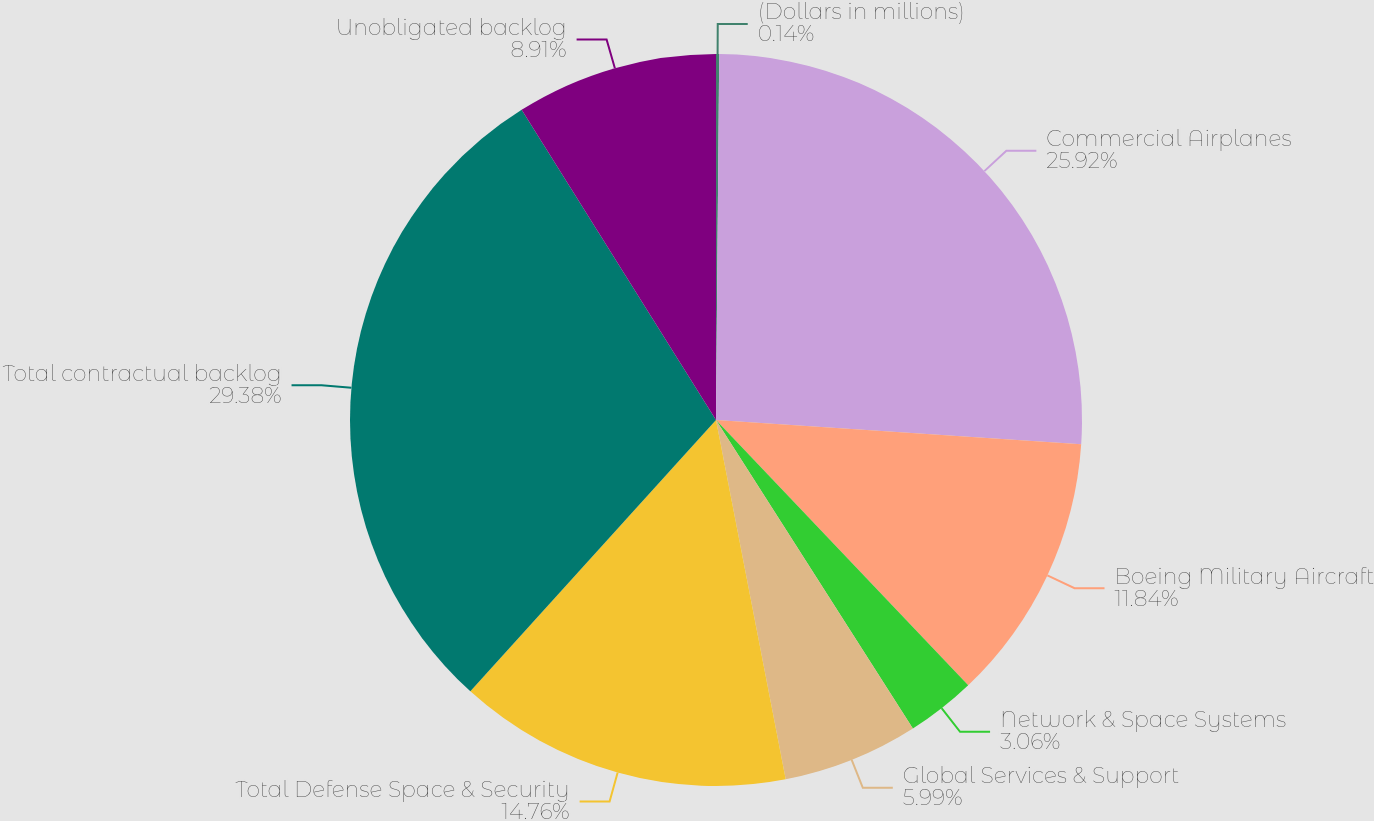Convert chart. <chart><loc_0><loc_0><loc_500><loc_500><pie_chart><fcel>(Dollars in millions)<fcel>Commercial Airplanes<fcel>Boeing Military Aircraft<fcel>Network & Space Systems<fcel>Global Services & Support<fcel>Total Defense Space & Security<fcel>Total contractual backlog<fcel>Unobligated backlog<nl><fcel>0.14%<fcel>25.92%<fcel>11.84%<fcel>3.06%<fcel>5.99%<fcel>14.76%<fcel>29.38%<fcel>8.91%<nl></chart> 